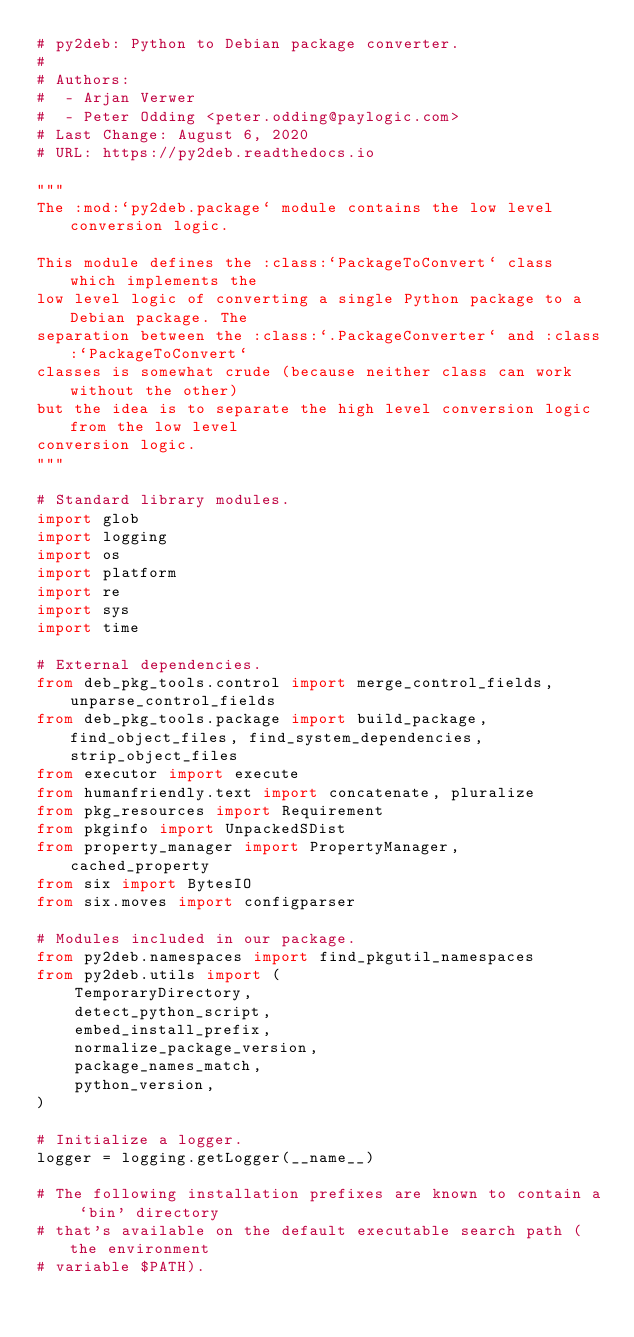Convert code to text. <code><loc_0><loc_0><loc_500><loc_500><_Python_># py2deb: Python to Debian package converter.
#
# Authors:
#  - Arjan Verwer
#  - Peter Odding <peter.odding@paylogic.com>
# Last Change: August 6, 2020
# URL: https://py2deb.readthedocs.io

"""
The :mod:`py2deb.package` module contains the low level conversion logic.

This module defines the :class:`PackageToConvert` class which implements the
low level logic of converting a single Python package to a Debian package. The
separation between the :class:`.PackageConverter` and :class:`PackageToConvert`
classes is somewhat crude (because neither class can work without the other)
but the idea is to separate the high level conversion logic from the low level
conversion logic.
"""

# Standard library modules.
import glob
import logging
import os
import platform
import re
import sys
import time

# External dependencies.
from deb_pkg_tools.control import merge_control_fields, unparse_control_fields
from deb_pkg_tools.package import build_package, find_object_files, find_system_dependencies, strip_object_files
from executor import execute
from humanfriendly.text import concatenate, pluralize
from pkg_resources import Requirement
from pkginfo import UnpackedSDist
from property_manager import PropertyManager, cached_property
from six import BytesIO
from six.moves import configparser

# Modules included in our package.
from py2deb.namespaces import find_pkgutil_namespaces
from py2deb.utils import (
    TemporaryDirectory,
    detect_python_script,
    embed_install_prefix,
    normalize_package_version,
    package_names_match,
    python_version,
)

# Initialize a logger.
logger = logging.getLogger(__name__)

# The following installation prefixes are known to contain a `bin' directory
# that's available on the default executable search path (the environment
# variable $PATH).</code> 